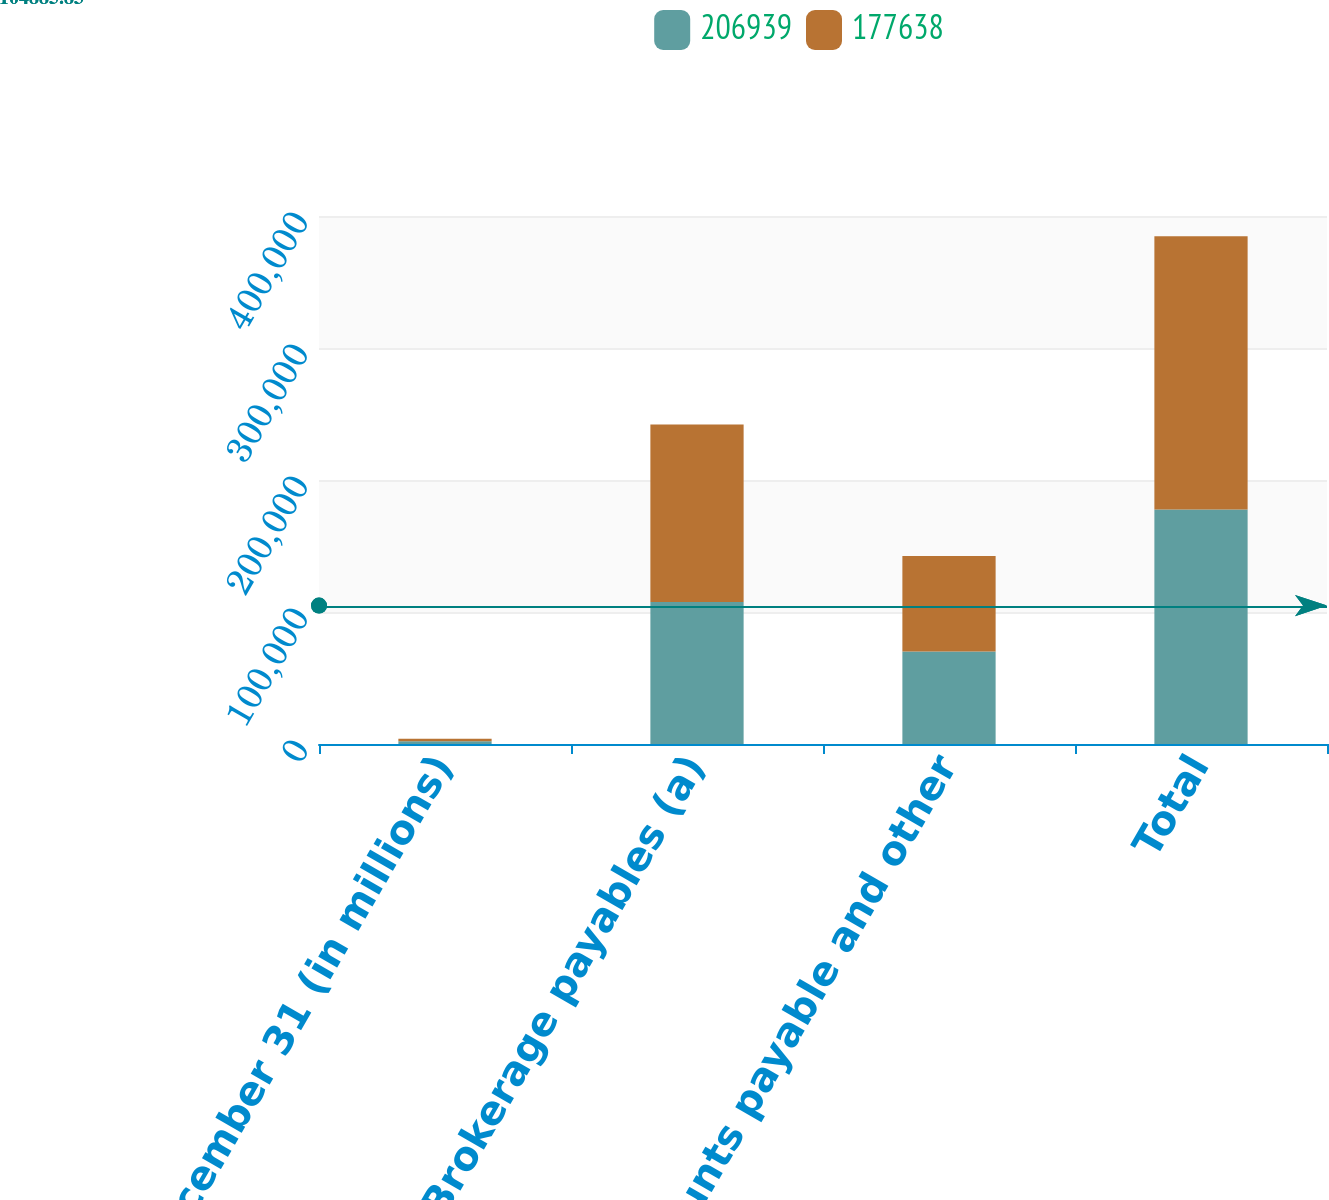<chart> <loc_0><loc_0><loc_500><loc_500><stacked_bar_chart><ecel><fcel>December 31 (in millions)<fcel>Brokerage payables (a)<fcel>Accounts payable and other<fcel>Total<nl><fcel>206939<fcel>2015<fcel>107632<fcel>70006<fcel>177638<nl><fcel>177638<fcel>2014<fcel>134467<fcel>72472<fcel>206939<nl></chart> 